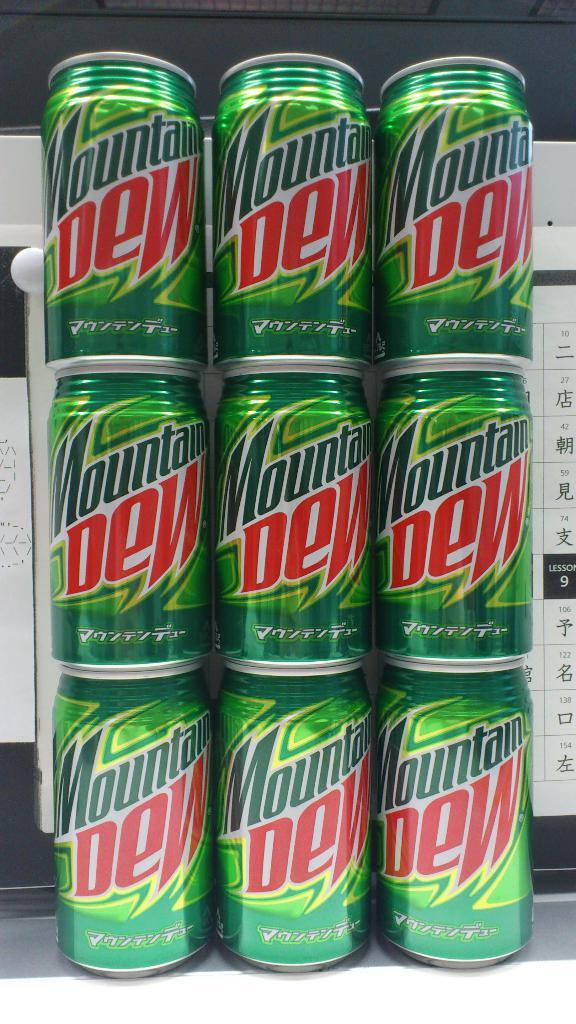<image>
Relay a brief, clear account of the picture shown. Nine cans of Mountain Dew are stacked up in three columns. 